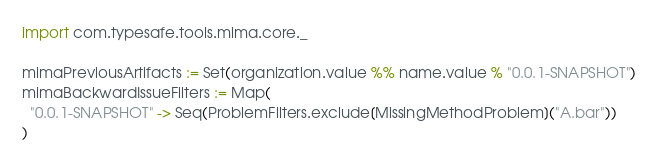Convert code to text. <code><loc_0><loc_0><loc_500><loc_500><_Scala_>import com.typesafe.tools.mima.core._

mimaPreviousArtifacts := Set(organization.value %% name.value % "0.0.1-SNAPSHOT")
mimaBackwardIssueFilters := Map(
  "0.0.1-SNAPSHOT" -> Seq(ProblemFilters.exclude[MissingMethodProblem]("A.bar"))
)
</code> 